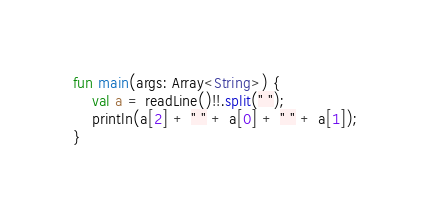<code> <loc_0><loc_0><loc_500><loc_500><_Kotlin_>fun main(args: Array<String>) {
    val a = readLine()!!.split(" ");
    println(a[2] + " " + a[0] + " " + a[1]);
}</code> 